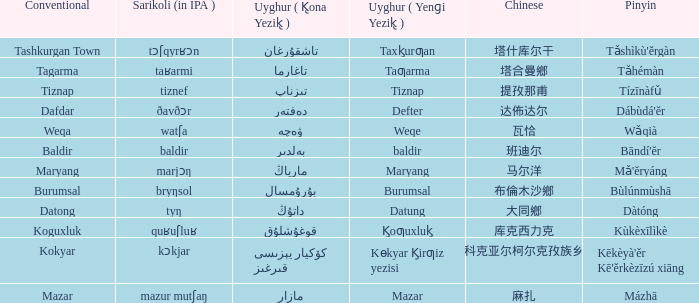Name the pinyin for  kɵkyar k̡irƣiz yezisi Kēkèyà'ěr Kē'ěrkèzīzú xiāng. Could you parse the entire table? {'header': ['Conventional', 'Sarikoli (in IPA )', 'Uyghur ( K̢ona Yezik̢ )', 'Uyghur ( Yenɡi Yezik̢ )', 'Chinese', 'Pinyin'], 'rows': [['Tashkurgan Town', 'tɔʃqyrʁɔn', 'تاشقۇرغان', 'Taxk̡urƣan', '塔什库尔干', "Tǎshìkù'ěrgàn"], ['Tagarma', 'taʁarmi', 'تاغارما', 'Taƣarma', '塔合曼鄉', 'Tǎhémàn'], ['Tiznap', 'tiznef', 'تىزناپ', 'Tiznap', '提孜那甫', 'Tízīnàfǔ'], ['Dafdar', 'ðavðɔr', 'دەفتەر', 'Defter', '达佈达尔', "Dábùdá'ĕr"], ['Weqa', 'watʃa', 'ۋەچە', 'Weqe', '瓦恰', 'Wǎqià'], ['Baldir', 'baldir', 'بەلدىر', 'baldir', '班迪尔', "Bāndí'ĕr"], ['Maryang', 'marjɔŋ', 'مارياڭ', 'Maryang', '马尔洋', "Mǎ'ĕryáng"], ['Burumsal', 'bryŋsol', 'بۇرۇمسال', 'Burumsal', '布倫木沙鄉', 'Bùlúnmùshā'], ['Datong', 'tyŋ', 'داتۇڭ', 'Datung', '大同鄉', 'Dàtóng'], ['Koguxluk', 'quʁuʃluʁ', 'قوغۇشلۇق', 'K̡oƣuxluk̡', '库克西力克', 'Kùkèxīlìkè'], ['Kokyar', 'kɔkjar', 'كۆكيار قىرغىز يېزىسى', 'Kɵkyar K̡irƣiz yezisi', '科克亚尔柯尔克孜族乡', "Kēkèyà'ěr Kē'ěrkèzīzú xiāng"], ['Mazar', 'mazur mutʃaŋ', 'مازار', 'Mazar', '麻扎', 'Mázhā']]} 